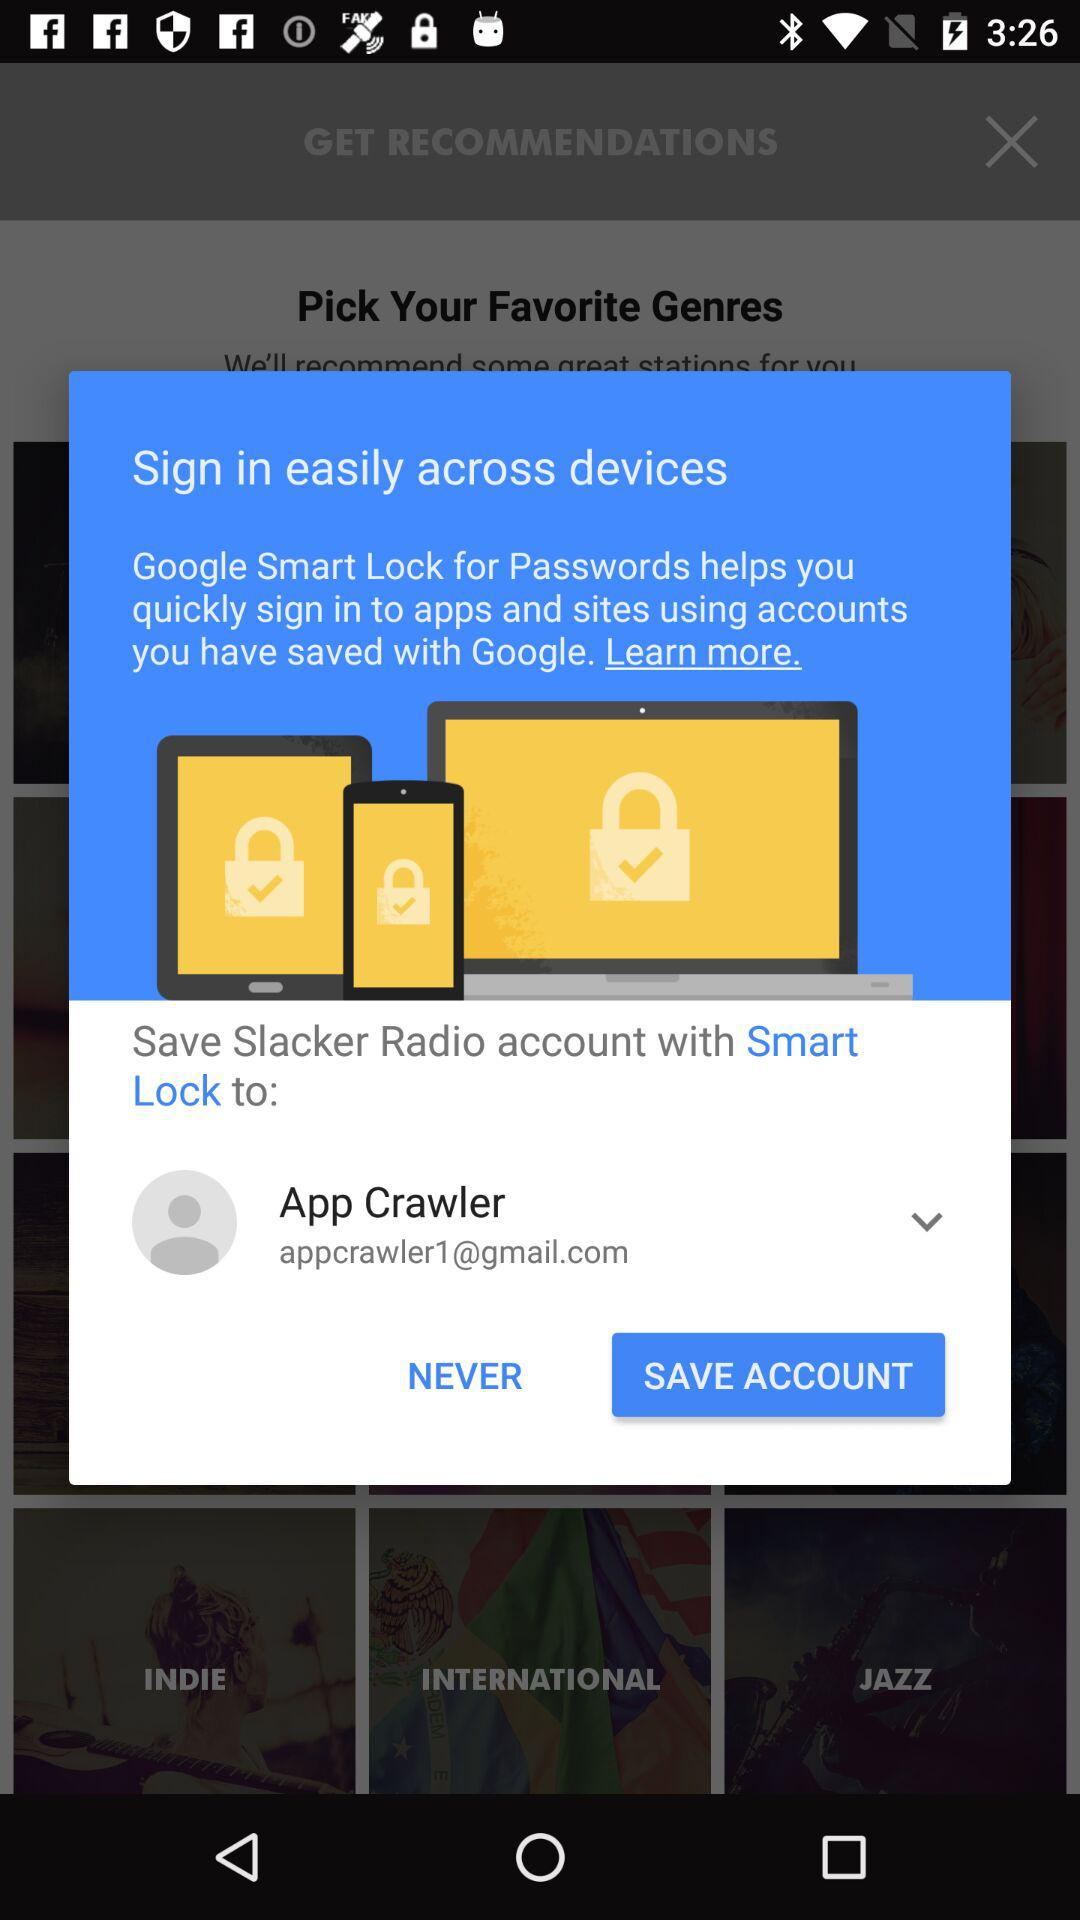What is the user name? The user name is App Crawler. 